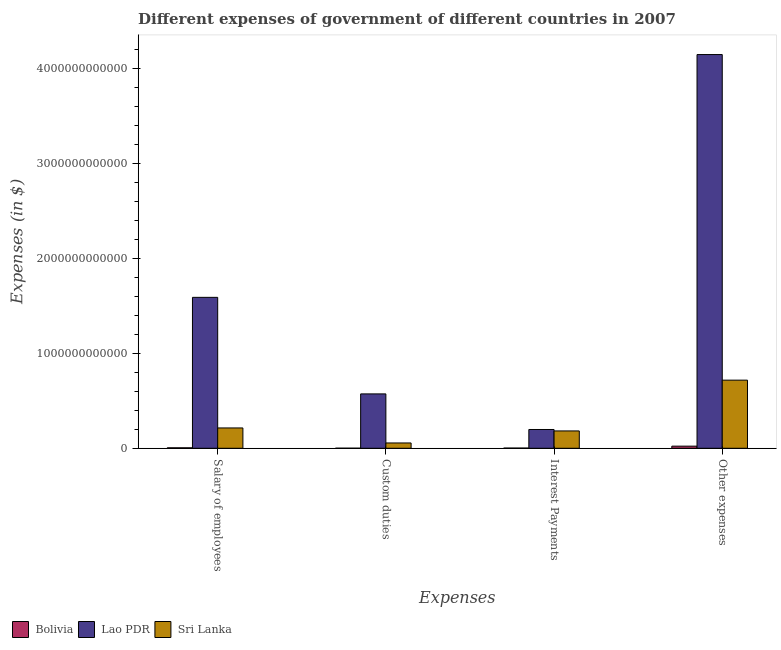How many different coloured bars are there?
Provide a succinct answer. 3. How many bars are there on the 3rd tick from the left?
Ensure brevity in your answer.  3. What is the label of the 3rd group of bars from the left?
Give a very brief answer. Interest Payments. What is the amount spent on salary of employees in Sri Lanka?
Your response must be concise. 2.14e+11. Across all countries, what is the maximum amount spent on other expenses?
Your response must be concise. 4.15e+12. Across all countries, what is the minimum amount spent on other expenses?
Offer a terse response. 2.25e+1. In which country was the amount spent on custom duties maximum?
Your answer should be compact. Lao PDR. In which country was the amount spent on salary of employees minimum?
Your answer should be compact. Bolivia. What is the total amount spent on other expenses in the graph?
Make the answer very short. 4.89e+12. What is the difference between the amount spent on custom duties in Lao PDR and that in Sri Lanka?
Provide a short and direct response. 5.17e+11. What is the difference between the amount spent on other expenses in Sri Lanka and the amount spent on custom duties in Lao PDR?
Keep it short and to the point. 1.45e+11. What is the average amount spent on salary of employees per country?
Your response must be concise. 6.03e+11. What is the difference between the amount spent on salary of employees and amount spent on other expenses in Sri Lanka?
Your response must be concise. -5.03e+11. In how many countries, is the amount spent on custom duties greater than 3600000000000 $?
Ensure brevity in your answer.  0. What is the ratio of the amount spent on salary of employees in Lao PDR to that in Bolivia?
Ensure brevity in your answer.  318.4. Is the amount spent on interest payments in Bolivia less than that in Lao PDR?
Offer a very short reply. Yes. Is the difference between the amount spent on interest payments in Lao PDR and Bolivia greater than the difference between the amount spent on salary of employees in Lao PDR and Bolivia?
Your answer should be compact. No. What is the difference between the highest and the second highest amount spent on custom duties?
Ensure brevity in your answer.  5.17e+11. What is the difference between the highest and the lowest amount spent on interest payments?
Offer a very short reply. 1.96e+11. In how many countries, is the amount spent on other expenses greater than the average amount spent on other expenses taken over all countries?
Your answer should be compact. 1. Is the sum of the amount spent on salary of employees in Lao PDR and Bolivia greater than the maximum amount spent on other expenses across all countries?
Offer a very short reply. No. Is it the case that in every country, the sum of the amount spent on custom duties and amount spent on other expenses is greater than the sum of amount spent on salary of employees and amount spent on interest payments?
Offer a very short reply. No. What does the 3rd bar from the left in Salary of employees represents?
Ensure brevity in your answer.  Sri Lanka. What does the 1st bar from the right in Other expenses represents?
Offer a very short reply. Sri Lanka. How many bars are there?
Provide a succinct answer. 12. Are all the bars in the graph horizontal?
Offer a very short reply. No. What is the difference between two consecutive major ticks on the Y-axis?
Ensure brevity in your answer.  1.00e+12. Does the graph contain any zero values?
Make the answer very short. No. Does the graph contain grids?
Your answer should be compact. No. Where does the legend appear in the graph?
Offer a terse response. Bottom left. What is the title of the graph?
Ensure brevity in your answer.  Different expenses of government of different countries in 2007. What is the label or title of the X-axis?
Your response must be concise. Expenses. What is the label or title of the Y-axis?
Provide a short and direct response. Expenses (in $). What is the Expenses (in $) in Bolivia in Salary of employees?
Keep it short and to the point. 4.99e+09. What is the Expenses (in $) in Lao PDR in Salary of employees?
Offer a very short reply. 1.59e+12. What is the Expenses (in $) of Sri Lanka in Salary of employees?
Offer a very short reply. 2.14e+11. What is the Expenses (in $) of Bolivia in Custom duties?
Offer a very short reply. 8.96e+08. What is the Expenses (in $) in Lao PDR in Custom duties?
Your response must be concise. 5.73e+11. What is the Expenses (in $) of Sri Lanka in Custom duties?
Offer a very short reply. 5.60e+1. What is the Expenses (in $) in Bolivia in Interest Payments?
Ensure brevity in your answer.  2.14e+09. What is the Expenses (in $) in Lao PDR in Interest Payments?
Your response must be concise. 1.98e+11. What is the Expenses (in $) in Sri Lanka in Interest Payments?
Provide a succinct answer. 1.83e+11. What is the Expenses (in $) of Bolivia in Other expenses?
Offer a terse response. 2.25e+1. What is the Expenses (in $) of Lao PDR in Other expenses?
Give a very brief answer. 4.15e+12. What is the Expenses (in $) in Sri Lanka in Other expenses?
Offer a very short reply. 7.17e+11. Across all Expenses, what is the maximum Expenses (in $) in Bolivia?
Provide a short and direct response. 2.25e+1. Across all Expenses, what is the maximum Expenses (in $) of Lao PDR?
Give a very brief answer. 4.15e+12. Across all Expenses, what is the maximum Expenses (in $) in Sri Lanka?
Your answer should be compact. 7.17e+11. Across all Expenses, what is the minimum Expenses (in $) in Bolivia?
Give a very brief answer. 8.96e+08. Across all Expenses, what is the minimum Expenses (in $) in Lao PDR?
Offer a very short reply. 1.98e+11. Across all Expenses, what is the minimum Expenses (in $) of Sri Lanka?
Offer a terse response. 5.60e+1. What is the total Expenses (in $) in Bolivia in the graph?
Make the answer very short. 3.05e+1. What is the total Expenses (in $) in Lao PDR in the graph?
Your answer should be very brief. 6.51e+12. What is the total Expenses (in $) of Sri Lanka in the graph?
Give a very brief answer. 1.17e+12. What is the difference between the Expenses (in $) of Bolivia in Salary of employees and that in Custom duties?
Offer a very short reply. 4.10e+09. What is the difference between the Expenses (in $) in Lao PDR in Salary of employees and that in Custom duties?
Provide a short and direct response. 1.02e+12. What is the difference between the Expenses (in $) in Sri Lanka in Salary of employees and that in Custom duties?
Make the answer very short. 1.58e+11. What is the difference between the Expenses (in $) in Bolivia in Salary of employees and that in Interest Payments?
Offer a very short reply. 2.85e+09. What is the difference between the Expenses (in $) in Lao PDR in Salary of employees and that in Interest Payments?
Provide a succinct answer. 1.39e+12. What is the difference between the Expenses (in $) of Sri Lanka in Salary of employees and that in Interest Payments?
Provide a succinct answer. 3.15e+1. What is the difference between the Expenses (in $) of Bolivia in Salary of employees and that in Other expenses?
Your answer should be compact. -1.75e+1. What is the difference between the Expenses (in $) in Lao PDR in Salary of employees and that in Other expenses?
Provide a short and direct response. -2.56e+12. What is the difference between the Expenses (in $) in Sri Lanka in Salary of employees and that in Other expenses?
Make the answer very short. -5.03e+11. What is the difference between the Expenses (in $) in Bolivia in Custom duties and that in Interest Payments?
Ensure brevity in your answer.  -1.25e+09. What is the difference between the Expenses (in $) of Lao PDR in Custom duties and that in Interest Payments?
Your response must be concise. 3.75e+11. What is the difference between the Expenses (in $) in Sri Lanka in Custom duties and that in Interest Payments?
Your response must be concise. -1.27e+11. What is the difference between the Expenses (in $) in Bolivia in Custom duties and that in Other expenses?
Keep it short and to the point. -2.16e+1. What is the difference between the Expenses (in $) of Lao PDR in Custom duties and that in Other expenses?
Make the answer very short. -3.57e+12. What is the difference between the Expenses (in $) in Sri Lanka in Custom duties and that in Other expenses?
Offer a terse response. -6.61e+11. What is the difference between the Expenses (in $) of Bolivia in Interest Payments and that in Other expenses?
Offer a very short reply. -2.03e+1. What is the difference between the Expenses (in $) of Lao PDR in Interest Payments and that in Other expenses?
Provide a short and direct response. -3.95e+12. What is the difference between the Expenses (in $) in Sri Lanka in Interest Payments and that in Other expenses?
Ensure brevity in your answer.  -5.35e+11. What is the difference between the Expenses (in $) in Bolivia in Salary of employees and the Expenses (in $) in Lao PDR in Custom duties?
Provide a succinct answer. -5.68e+11. What is the difference between the Expenses (in $) of Bolivia in Salary of employees and the Expenses (in $) of Sri Lanka in Custom duties?
Make the answer very short. -5.10e+1. What is the difference between the Expenses (in $) of Lao PDR in Salary of employees and the Expenses (in $) of Sri Lanka in Custom duties?
Make the answer very short. 1.53e+12. What is the difference between the Expenses (in $) of Bolivia in Salary of employees and the Expenses (in $) of Lao PDR in Interest Payments?
Keep it short and to the point. -1.93e+11. What is the difference between the Expenses (in $) of Bolivia in Salary of employees and the Expenses (in $) of Sri Lanka in Interest Payments?
Your answer should be very brief. -1.78e+11. What is the difference between the Expenses (in $) of Lao PDR in Salary of employees and the Expenses (in $) of Sri Lanka in Interest Payments?
Ensure brevity in your answer.  1.41e+12. What is the difference between the Expenses (in $) in Bolivia in Salary of employees and the Expenses (in $) in Lao PDR in Other expenses?
Your answer should be compact. -4.14e+12. What is the difference between the Expenses (in $) of Bolivia in Salary of employees and the Expenses (in $) of Sri Lanka in Other expenses?
Offer a terse response. -7.12e+11. What is the difference between the Expenses (in $) in Lao PDR in Salary of employees and the Expenses (in $) in Sri Lanka in Other expenses?
Offer a very short reply. 8.72e+11. What is the difference between the Expenses (in $) of Bolivia in Custom duties and the Expenses (in $) of Lao PDR in Interest Payments?
Give a very brief answer. -1.97e+11. What is the difference between the Expenses (in $) in Bolivia in Custom duties and the Expenses (in $) in Sri Lanka in Interest Payments?
Provide a succinct answer. -1.82e+11. What is the difference between the Expenses (in $) of Lao PDR in Custom duties and the Expenses (in $) of Sri Lanka in Interest Payments?
Your response must be concise. 3.90e+11. What is the difference between the Expenses (in $) in Bolivia in Custom duties and the Expenses (in $) in Lao PDR in Other expenses?
Your answer should be very brief. -4.15e+12. What is the difference between the Expenses (in $) of Bolivia in Custom duties and the Expenses (in $) of Sri Lanka in Other expenses?
Your response must be concise. -7.17e+11. What is the difference between the Expenses (in $) of Lao PDR in Custom duties and the Expenses (in $) of Sri Lanka in Other expenses?
Make the answer very short. -1.45e+11. What is the difference between the Expenses (in $) of Bolivia in Interest Payments and the Expenses (in $) of Lao PDR in Other expenses?
Offer a terse response. -4.14e+12. What is the difference between the Expenses (in $) of Bolivia in Interest Payments and the Expenses (in $) of Sri Lanka in Other expenses?
Your answer should be compact. -7.15e+11. What is the difference between the Expenses (in $) of Lao PDR in Interest Payments and the Expenses (in $) of Sri Lanka in Other expenses?
Your response must be concise. -5.20e+11. What is the average Expenses (in $) of Bolivia per Expenses?
Your answer should be compact. 7.62e+09. What is the average Expenses (in $) of Lao PDR per Expenses?
Provide a succinct answer. 1.63e+12. What is the average Expenses (in $) in Sri Lanka per Expenses?
Provide a short and direct response. 2.93e+11. What is the difference between the Expenses (in $) of Bolivia and Expenses (in $) of Lao PDR in Salary of employees?
Provide a succinct answer. -1.58e+12. What is the difference between the Expenses (in $) in Bolivia and Expenses (in $) in Sri Lanka in Salary of employees?
Offer a terse response. -2.09e+11. What is the difference between the Expenses (in $) of Lao PDR and Expenses (in $) of Sri Lanka in Salary of employees?
Provide a succinct answer. 1.38e+12. What is the difference between the Expenses (in $) of Bolivia and Expenses (in $) of Lao PDR in Custom duties?
Your answer should be compact. -5.72e+11. What is the difference between the Expenses (in $) of Bolivia and Expenses (in $) of Sri Lanka in Custom duties?
Provide a succinct answer. -5.51e+1. What is the difference between the Expenses (in $) of Lao PDR and Expenses (in $) of Sri Lanka in Custom duties?
Keep it short and to the point. 5.17e+11. What is the difference between the Expenses (in $) in Bolivia and Expenses (in $) in Lao PDR in Interest Payments?
Ensure brevity in your answer.  -1.96e+11. What is the difference between the Expenses (in $) of Bolivia and Expenses (in $) of Sri Lanka in Interest Payments?
Provide a short and direct response. -1.81e+11. What is the difference between the Expenses (in $) in Lao PDR and Expenses (in $) in Sri Lanka in Interest Payments?
Keep it short and to the point. 1.51e+1. What is the difference between the Expenses (in $) of Bolivia and Expenses (in $) of Lao PDR in Other expenses?
Make the answer very short. -4.12e+12. What is the difference between the Expenses (in $) of Bolivia and Expenses (in $) of Sri Lanka in Other expenses?
Your response must be concise. -6.95e+11. What is the difference between the Expenses (in $) in Lao PDR and Expenses (in $) in Sri Lanka in Other expenses?
Provide a succinct answer. 3.43e+12. What is the ratio of the Expenses (in $) of Bolivia in Salary of employees to that in Custom duties?
Provide a short and direct response. 5.57. What is the ratio of the Expenses (in $) of Lao PDR in Salary of employees to that in Custom duties?
Make the answer very short. 2.78. What is the ratio of the Expenses (in $) in Sri Lanka in Salary of employees to that in Custom duties?
Provide a succinct answer. 3.83. What is the ratio of the Expenses (in $) of Bolivia in Salary of employees to that in Interest Payments?
Provide a succinct answer. 2.33. What is the ratio of the Expenses (in $) of Lao PDR in Salary of employees to that in Interest Payments?
Give a very brief answer. 8.03. What is the ratio of the Expenses (in $) of Sri Lanka in Salary of employees to that in Interest Payments?
Your response must be concise. 1.17. What is the ratio of the Expenses (in $) in Bolivia in Salary of employees to that in Other expenses?
Give a very brief answer. 0.22. What is the ratio of the Expenses (in $) in Lao PDR in Salary of employees to that in Other expenses?
Ensure brevity in your answer.  0.38. What is the ratio of the Expenses (in $) in Sri Lanka in Salary of employees to that in Other expenses?
Provide a short and direct response. 0.3. What is the ratio of the Expenses (in $) in Bolivia in Custom duties to that in Interest Payments?
Your answer should be compact. 0.42. What is the ratio of the Expenses (in $) of Lao PDR in Custom duties to that in Interest Payments?
Keep it short and to the point. 2.89. What is the ratio of the Expenses (in $) in Sri Lanka in Custom duties to that in Interest Payments?
Offer a very short reply. 0.31. What is the ratio of the Expenses (in $) of Bolivia in Custom duties to that in Other expenses?
Ensure brevity in your answer.  0.04. What is the ratio of the Expenses (in $) in Lao PDR in Custom duties to that in Other expenses?
Provide a short and direct response. 0.14. What is the ratio of the Expenses (in $) in Sri Lanka in Custom duties to that in Other expenses?
Offer a terse response. 0.08. What is the ratio of the Expenses (in $) of Bolivia in Interest Payments to that in Other expenses?
Offer a very short reply. 0.1. What is the ratio of the Expenses (in $) in Lao PDR in Interest Payments to that in Other expenses?
Give a very brief answer. 0.05. What is the ratio of the Expenses (in $) in Sri Lanka in Interest Payments to that in Other expenses?
Provide a short and direct response. 0.25. What is the difference between the highest and the second highest Expenses (in $) of Bolivia?
Give a very brief answer. 1.75e+1. What is the difference between the highest and the second highest Expenses (in $) in Lao PDR?
Give a very brief answer. 2.56e+12. What is the difference between the highest and the second highest Expenses (in $) of Sri Lanka?
Provide a short and direct response. 5.03e+11. What is the difference between the highest and the lowest Expenses (in $) in Bolivia?
Ensure brevity in your answer.  2.16e+1. What is the difference between the highest and the lowest Expenses (in $) in Lao PDR?
Provide a succinct answer. 3.95e+12. What is the difference between the highest and the lowest Expenses (in $) in Sri Lanka?
Your response must be concise. 6.61e+11. 